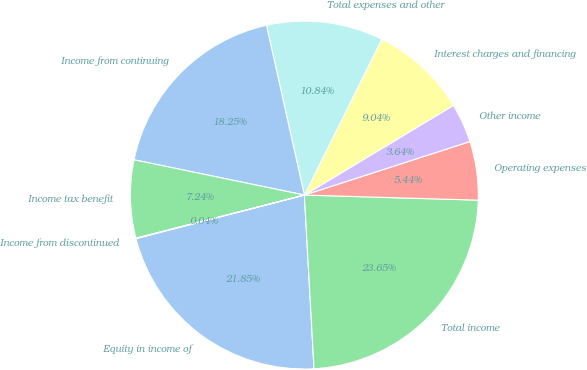Convert chart. <chart><loc_0><loc_0><loc_500><loc_500><pie_chart><fcel>Equity in income of<fcel>Total income<fcel>Operating expenses<fcel>Other income<fcel>Interest charges and financing<fcel>Total expenses and other<fcel>Income from continuing<fcel>Income tax benefit<fcel>Income from discontinued<nl><fcel>21.85%<fcel>23.65%<fcel>5.44%<fcel>3.64%<fcel>9.04%<fcel>10.84%<fcel>18.25%<fcel>7.24%<fcel>0.04%<nl></chart> 